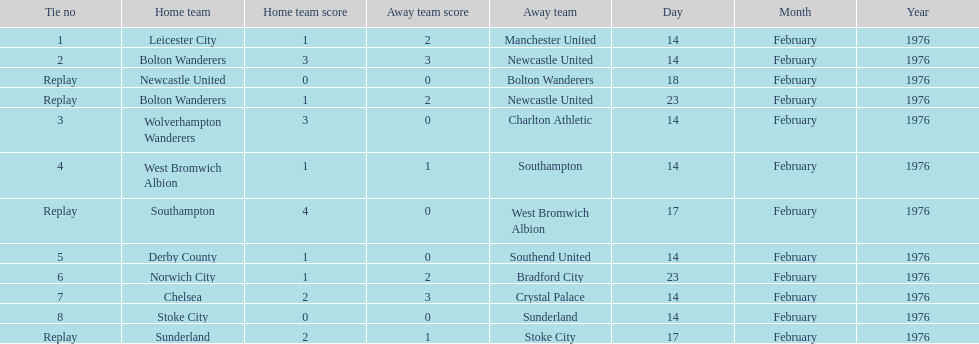How many teams played on february 14th, 1976? 7. Help me parse the entirety of this table. {'header': ['Tie no', 'Home team', 'Home team score', 'Away team score', 'Away team', 'Day', 'Month', 'Year'], 'rows': [['1', 'Leicester City', '1', '2', 'Manchester United', '14', 'February', '1976'], ['2', 'Bolton Wanderers', '3', '3', 'Newcastle United', '14', 'February', '1976'], ['Replay', 'Newcastle United', '0', '0', 'Bolton Wanderers', '18', 'February', '1976'], ['Replay', 'Bolton Wanderers', '1', '2', 'Newcastle United', '23', 'February', '1976'], ['3', 'Wolverhampton Wanderers', '3', '0', 'Charlton Athletic', '14', 'February', '1976'], ['4', 'West Bromwich Albion', '1', '1', 'Southampton', '14', 'February', '1976'], ['Replay', 'Southampton', '4', '0', 'West Bromwich Albion', '17', 'February', '1976'], ['5', 'Derby County', '1', '0', 'Southend United', '14', 'February', '1976'], ['6', 'Norwich City', '1', '2', 'Bradford City', '23', 'February', '1976'], ['7', 'Chelsea', '2', '3', 'Crystal Palace', '14', 'February', '1976'], ['8', 'Stoke City', '0', '0', 'Sunderland', '14', 'February', '1976'], ['Replay', 'Sunderland', '2', '1', 'Stoke City', '17', 'February', '1976']]} 